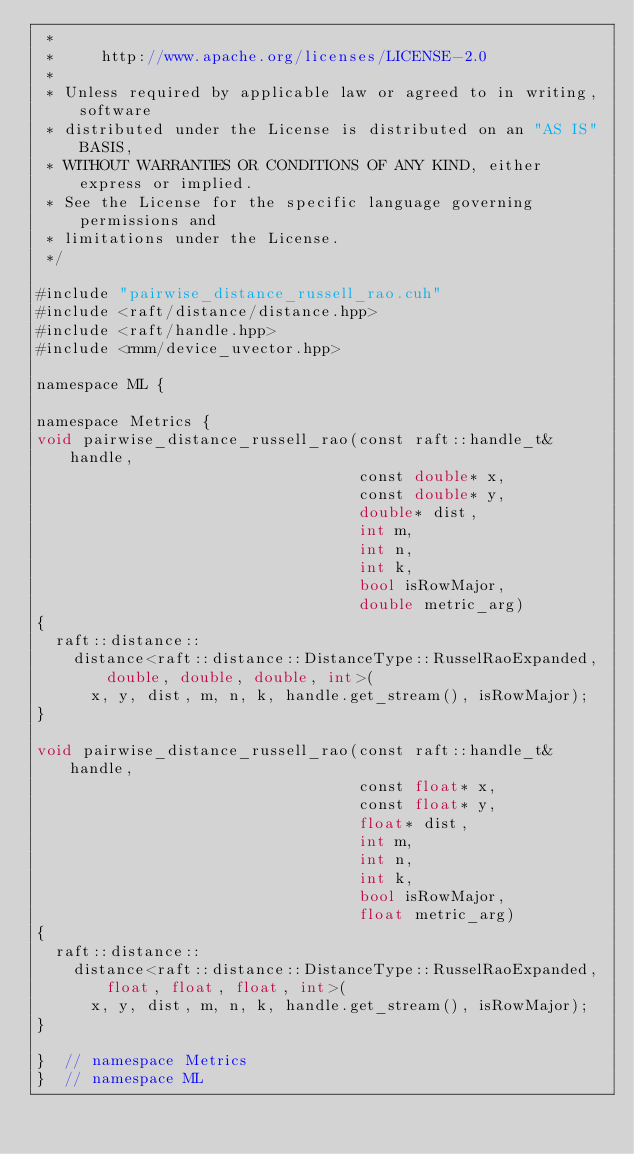Convert code to text. <code><loc_0><loc_0><loc_500><loc_500><_Cuda_> *
 *     http://www.apache.org/licenses/LICENSE-2.0
 *
 * Unless required by applicable law or agreed to in writing, software
 * distributed under the License is distributed on an "AS IS" BASIS,
 * WITHOUT WARRANTIES OR CONDITIONS OF ANY KIND, either express or implied.
 * See the License for the specific language governing permissions and
 * limitations under the License.
 */

#include "pairwise_distance_russell_rao.cuh"
#include <raft/distance/distance.hpp>
#include <raft/handle.hpp>
#include <rmm/device_uvector.hpp>

namespace ML {

namespace Metrics {
void pairwise_distance_russell_rao(const raft::handle_t& handle,
                                   const double* x,
                                   const double* y,
                                   double* dist,
                                   int m,
                                   int n,
                                   int k,
                                   bool isRowMajor,
                                   double metric_arg)
{
  raft::distance::
    distance<raft::distance::DistanceType::RusselRaoExpanded, double, double, double, int>(
      x, y, dist, m, n, k, handle.get_stream(), isRowMajor);
}

void pairwise_distance_russell_rao(const raft::handle_t& handle,
                                   const float* x,
                                   const float* y,
                                   float* dist,
                                   int m,
                                   int n,
                                   int k,
                                   bool isRowMajor,
                                   float metric_arg)
{
  raft::distance::
    distance<raft::distance::DistanceType::RusselRaoExpanded, float, float, float, int>(
      x, y, dist, m, n, k, handle.get_stream(), isRowMajor);
}

}  // namespace Metrics
}  // namespace ML
</code> 